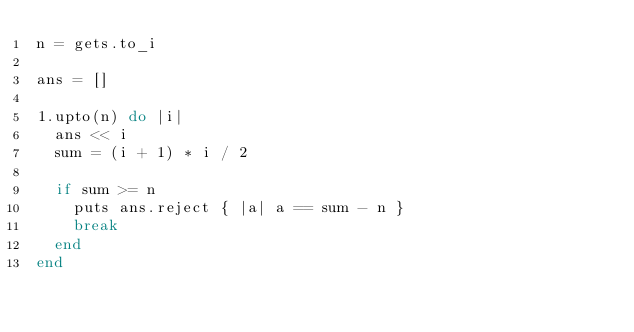<code> <loc_0><loc_0><loc_500><loc_500><_Ruby_>n = gets.to_i

ans = []

1.upto(n) do |i|
  ans << i
  sum = (i + 1) * i / 2

  if sum >= n
    puts ans.reject { |a| a == sum - n }
    break
  end
end
</code> 